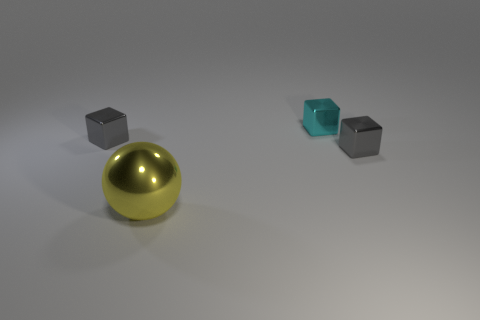Add 3 red metallic cubes. How many objects exist? 7 Subtract all cubes. How many objects are left? 1 Subtract all large yellow metal things. Subtract all large yellow spheres. How many objects are left? 2 Add 2 small cubes. How many small cubes are left? 5 Add 3 metal spheres. How many metal spheres exist? 4 Subtract 0 purple balls. How many objects are left? 4 